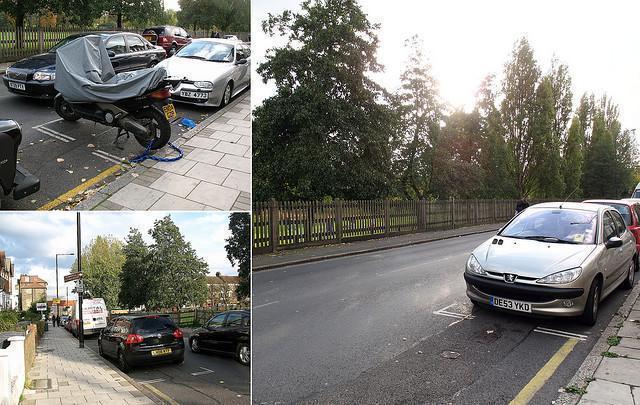What does the grey cloth do?
Select the correct answer and articulate reasoning with the following format: 'Answer: answer
Rationale: rationale.'
Options: Hide motorcycle, prevent scratches, prevent bugs, keep dry. Answer: keep dry.
Rationale: The cloth keeps dry. 